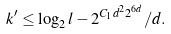Convert formula to latex. <formula><loc_0><loc_0><loc_500><loc_500>k ^ { \prime } \leq \log _ { 2 } l - 2 ^ { C _ { 1 } d ^ { 2 } 2 ^ { 6 d } } / d .</formula> 